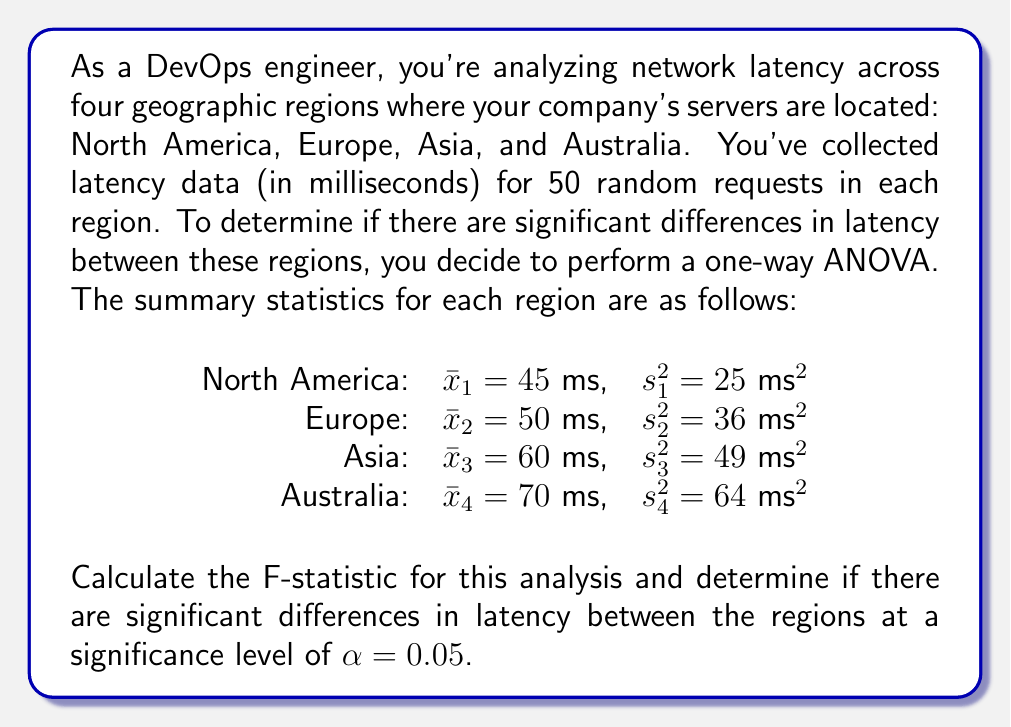Teach me how to tackle this problem. To solve this problem, we'll follow these steps:

1. Calculate the between-group sum of squares (SSB)
2. Calculate the within-group sum of squares (SSW)
3. Determine the degrees of freedom
4. Calculate the mean square between (MSB) and mean square within (MSW)
5. Compute the F-statistic
6. Compare the F-statistic to the critical F-value

Step 1: Calculate SSB
First, we need to find the grand mean:
$$\bar{x} = \frac{45 + 50 + 60 + 70}{4} = 56.25$$

Now, we can calculate SSB:
$$SSB = \sum_{i=1}^{k} n_i(\bar{x}_i - \bar{x})^2$$
$$SSB = 50[(45 - 56.25)^2 + (50 - 56.25)^2 + (60 - 56.25)^2 + (70 - 56.25)^2]$$
$$SSB = 50[(-11.25)^2 + (-6.25)^2 + (3.75)^2 + (13.75)^2]$$
$$SSB = 50[126.5625 + 39.0625 + 14.0625 + 189.0625]$$
$$SSB = 50(368.75) = 18,437.5$$

Step 2: Calculate SSW
$$SSW = \sum_{i=1}^{k} (n_i - 1)s_i^2$$
$$SSW = 49(25 + 36 + 49 + 64)$$
$$SSW = 49(174) = 8,526$$

Step 3: Determine degrees of freedom
Between-group df: $df_B = k - 1 = 4 - 1 = 3$
Within-group df: $df_W = N - k = 200 - 4 = 196$
Where k is the number of groups and N is the total number of observations.

Step 4: Calculate MSB and MSW
$$MSB = \frac{SSB}{df_B} = \frac{18,437.5}{3} = 6,145.83$$
$$MSW = \frac{SSW}{df_W} = \frac{8,526}{196} = 43.5$$

Step 5: Compute the F-statistic
$$F = \frac{MSB}{MSW} = \frac{6,145.83}{43.5} = 141.28$$

Step 6: Compare to critical F-value
For $\alpha = 0.05$, $df_B = 3$, and $df_W = 196$, the critical F-value is approximately 2.65 (from F-distribution table).

Since our calculated F-statistic (141.28) is much larger than the critical F-value (2.65), we reject the null hypothesis.
Answer: The F-statistic is 141.28. There are significant differences in latency between the regions at the 0.05 significance level, as the calculated F-statistic (141.28) is greater than the critical F-value (2.65). 